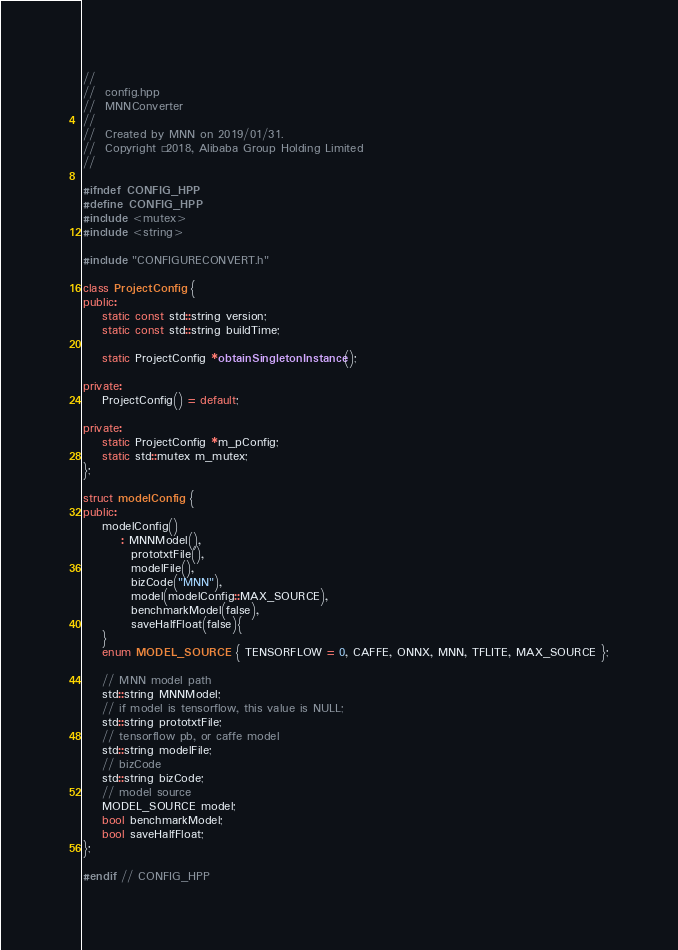<code> <loc_0><loc_0><loc_500><loc_500><_C++_>//
//  config.hpp
//  MNNConverter
//
//  Created by MNN on 2019/01/31.
//  Copyright © 2018, Alibaba Group Holding Limited
//

#ifndef CONFIG_HPP
#define CONFIG_HPP
#include <mutex>
#include <string>

#include "CONFIGURECONVERT.h"

class ProjectConfig {
public:
    static const std::string version;
    static const std::string buildTime;

    static ProjectConfig *obtainSingletonInstance();

private:
    ProjectConfig() = default;

private:
    static ProjectConfig *m_pConfig;
    static std::mutex m_mutex;
};

struct modelConfig {
public:
    modelConfig()
        : MNNModel(),
          prototxtFile(),
          modelFile(),
          bizCode("MNN"),
          model(modelConfig::MAX_SOURCE),
          benchmarkModel(false),
          saveHalfFloat(false){
    }
    enum MODEL_SOURCE { TENSORFLOW = 0, CAFFE, ONNX, MNN, TFLITE, MAX_SOURCE };

    // MNN model path
    std::string MNNModel;
    // if model is tensorflow, this value is NULL;
    std::string prototxtFile;
    // tensorflow pb, or caffe model
    std::string modelFile;
    // bizCode
    std::string bizCode;
    // model source
    MODEL_SOURCE model;
    bool benchmarkModel;
    bool saveHalfFloat;
};

#endif // CONFIG_HPP
</code> 